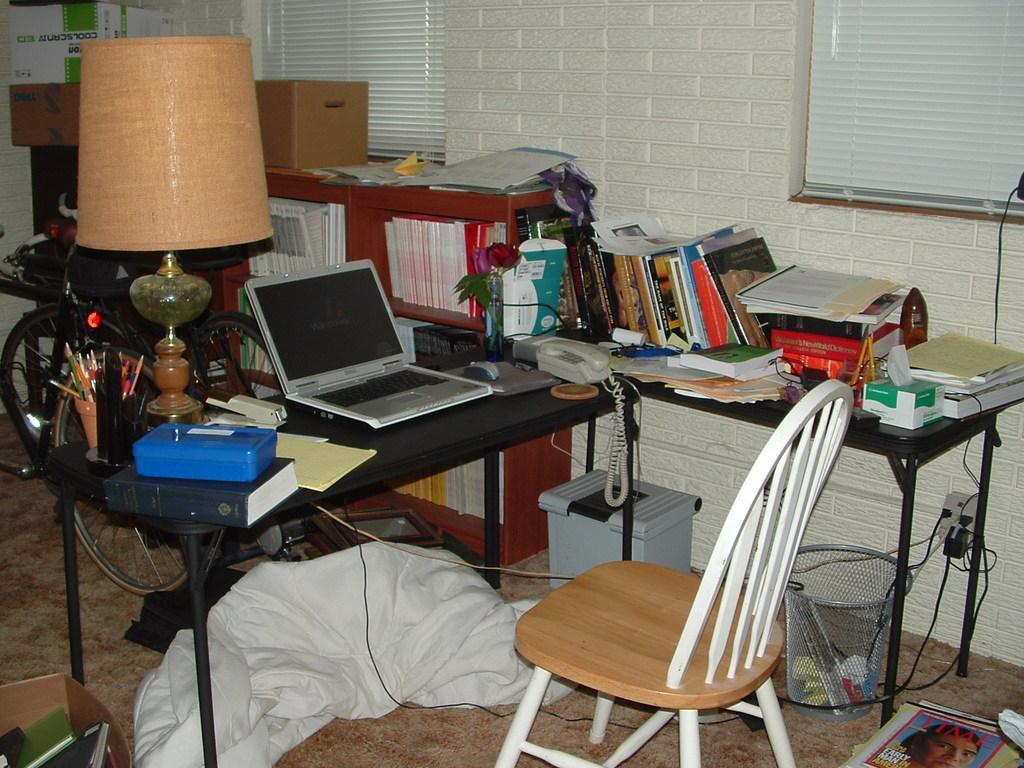Describe this image in one or two sentences. This is an image clicked inside the room. In the middle of the image there is a table. On that box,book, laptop, telephone are placed. In the background there is a rack, in that few books are arranged. On the left side there is a bicycle. On the right side of the image there is a table, on that few books and a box are there. In front of these tables there is a chair. On the floor I can see a white color cloth and a dustbin. On the top of the image there is a screen. 